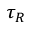<formula> <loc_0><loc_0><loc_500><loc_500>\tau _ { R }</formula> 